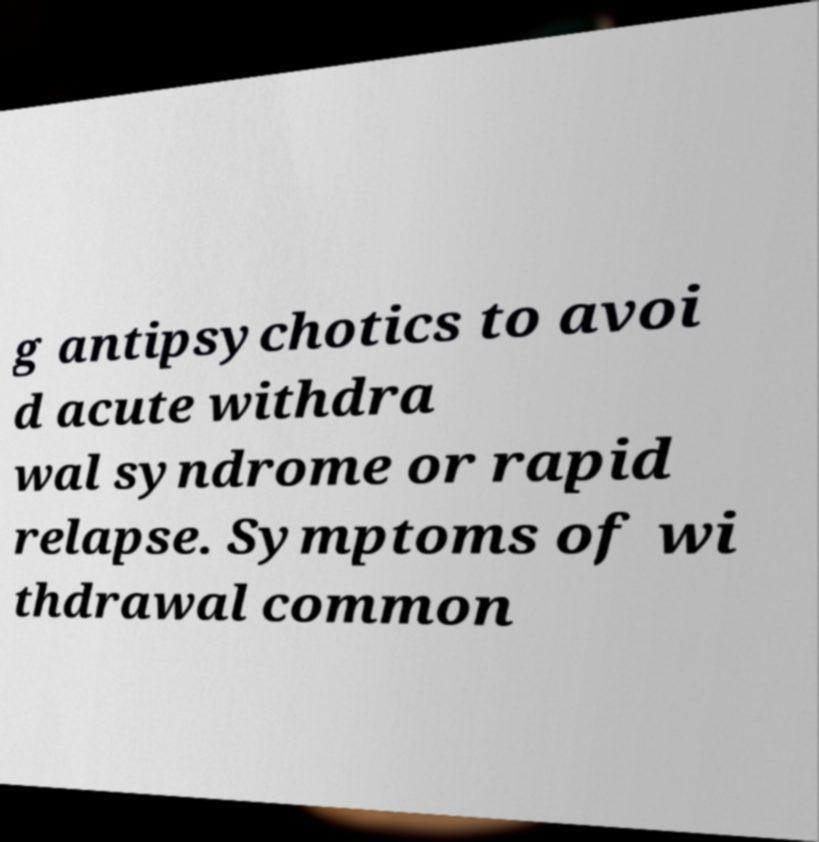For documentation purposes, I need the text within this image transcribed. Could you provide that? g antipsychotics to avoi d acute withdra wal syndrome or rapid relapse. Symptoms of wi thdrawal common 